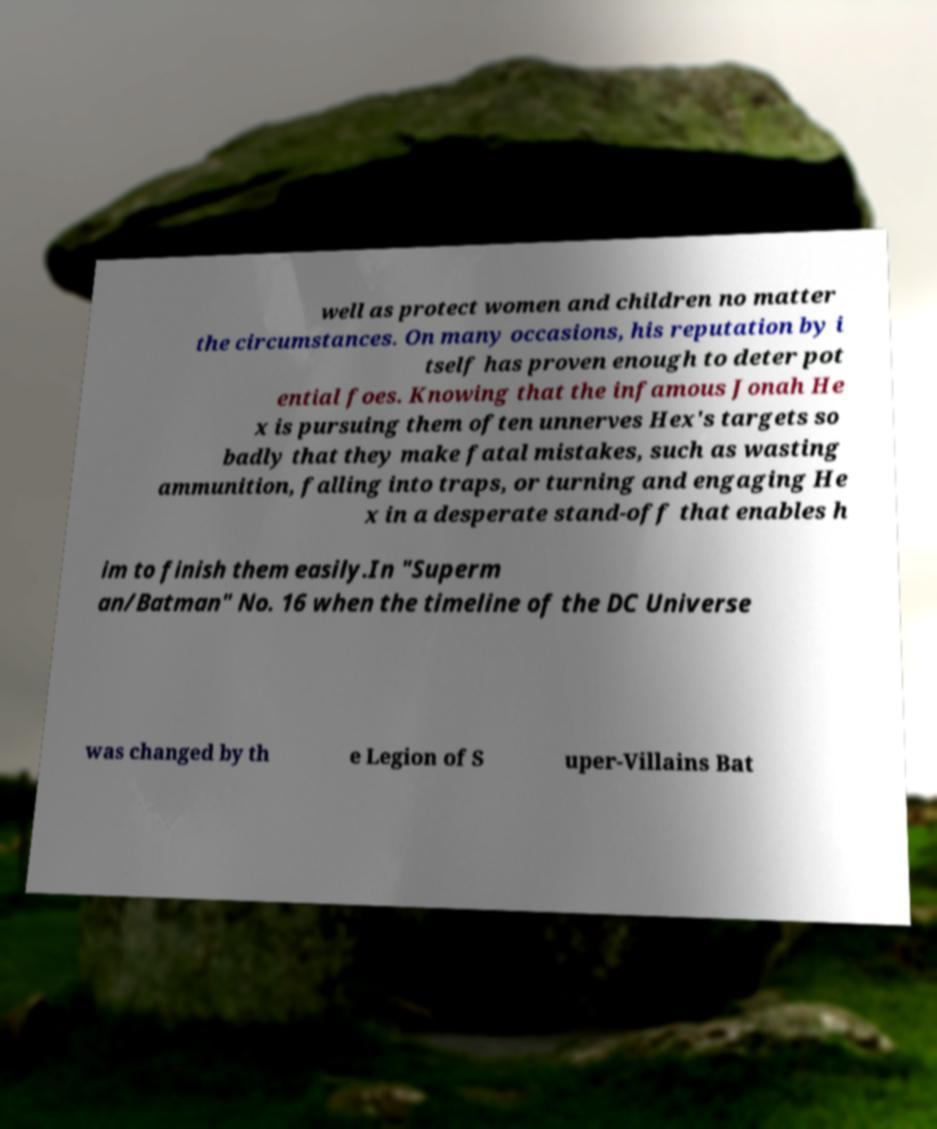What messages or text are displayed in this image? I need them in a readable, typed format. well as protect women and children no matter the circumstances. On many occasions, his reputation by i tself has proven enough to deter pot ential foes. Knowing that the infamous Jonah He x is pursuing them often unnerves Hex's targets so badly that they make fatal mistakes, such as wasting ammunition, falling into traps, or turning and engaging He x in a desperate stand-off that enables h im to finish them easily.In "Superm an/Batman" No. 16 when the timeline of the DC Universe was changed by th e Legion of S uper-Villains Bat 